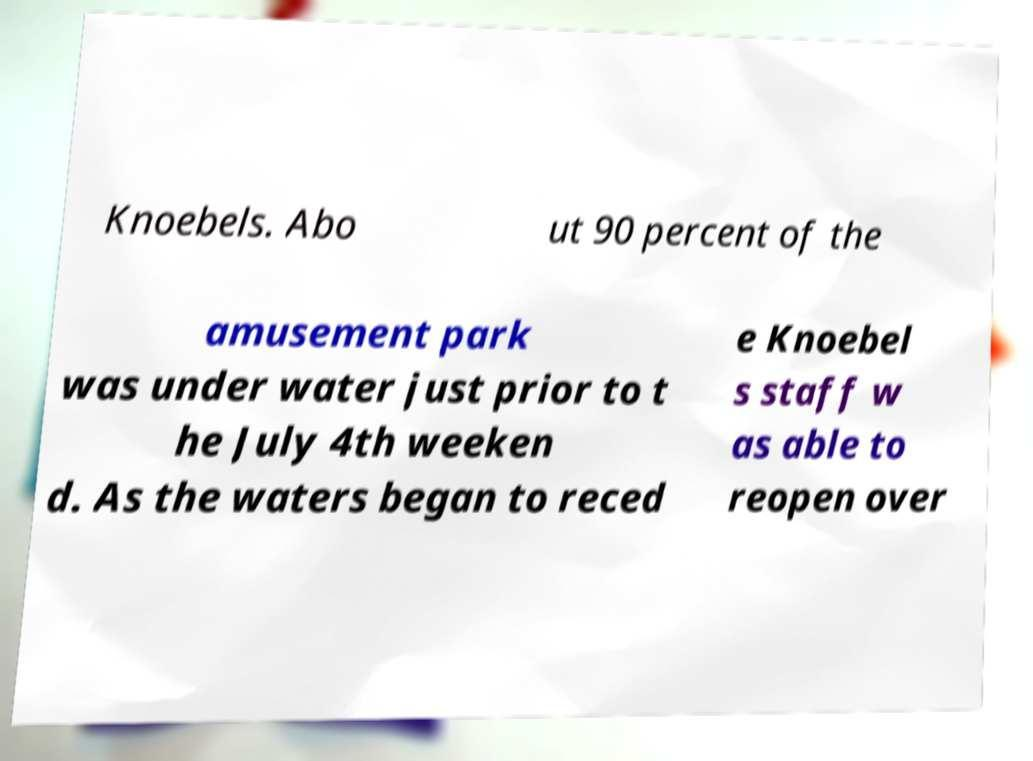Could you extract and type out the text from this image? Knoebels. Abo ut 90 percent of the amusement park was under water just prior to t he July 4th weeken d. As the waters began to reced e Knoebel s staff w as able to reopen over 